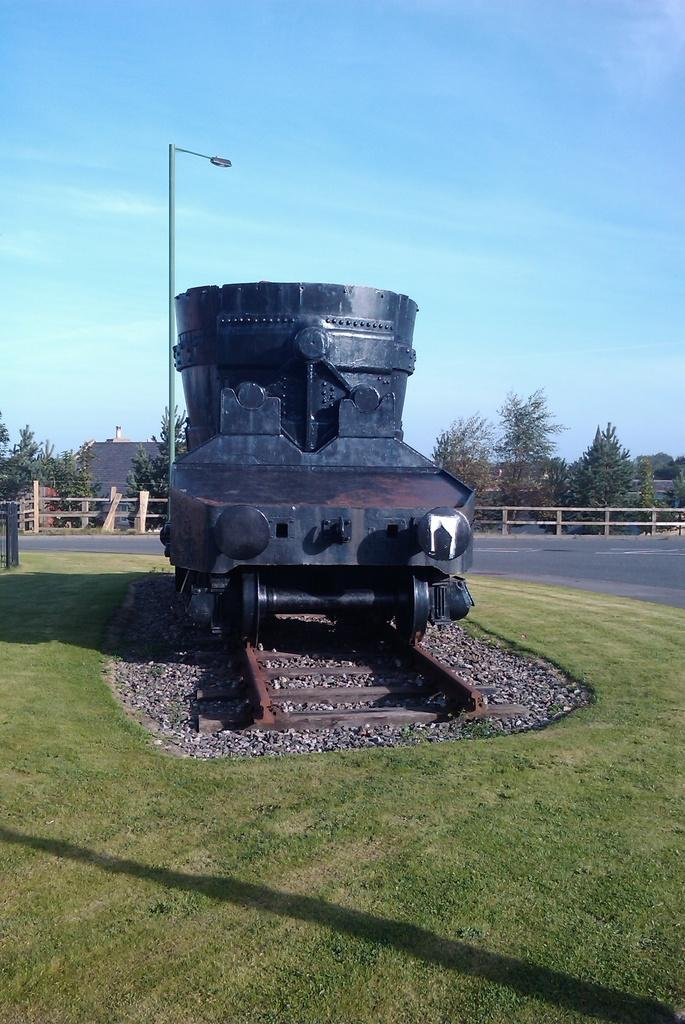What is placed on the ground in the image? There is a sculpture placed on the ground in the image. What can be seen in the background of the image? There is a wooden grill, trees, buildings, a street pole, a street light, and the sky visible in the background of the image. What is the condition of the sky in the image? The sky is visible in the background of the image, and clouds are present. Can you tell me how many pets are playing in the sand in the image? There are no pets or sand present in the image. What type of frog can be seen sitting on the street pole in the image? There is no frog present in the image, let alone on the street pole. 